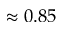Convert formula to latex. <formula><loc_0><loc_0><loc_500><loc_500>\approx 0 . 8 5</formula> 